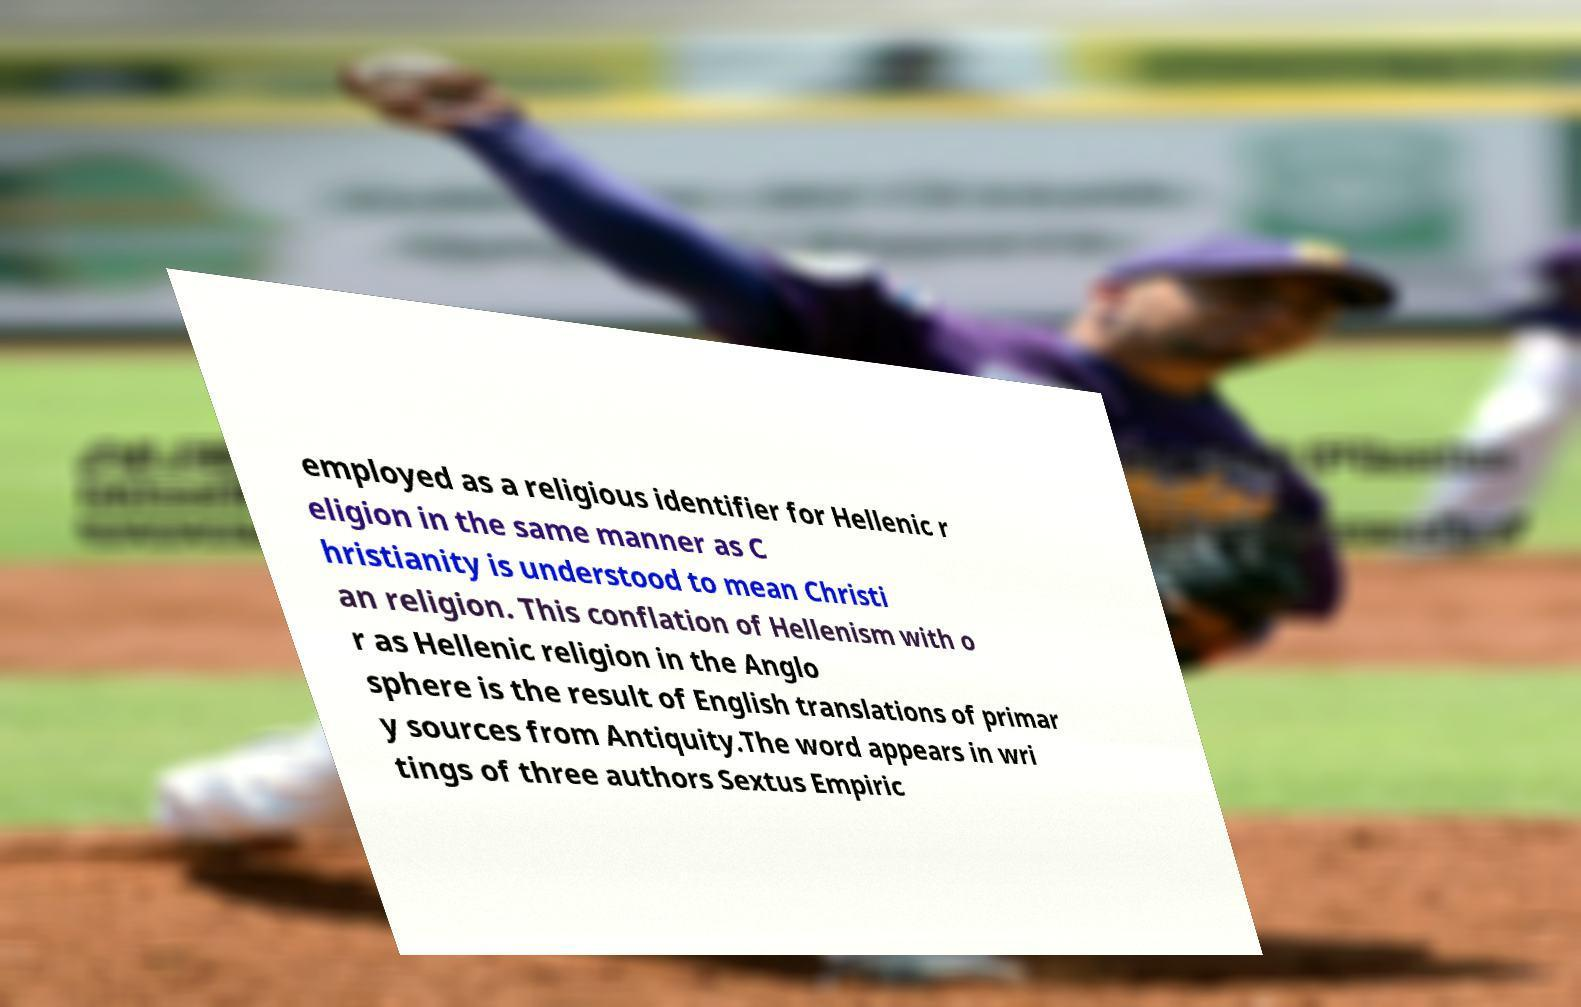I need the written content from this picture converted into text. Can you do that? employed as a religious identifier for Hellenic r eligion in the same manner as C hristianity is understood to mean Christi an religion. This conflation of Hellenism with o r as Hellenic religion in the Anglo sphere is the result of English translations of primar y sources from Antiquity.The word appears in wri tings of three authors Sextus Empiric 